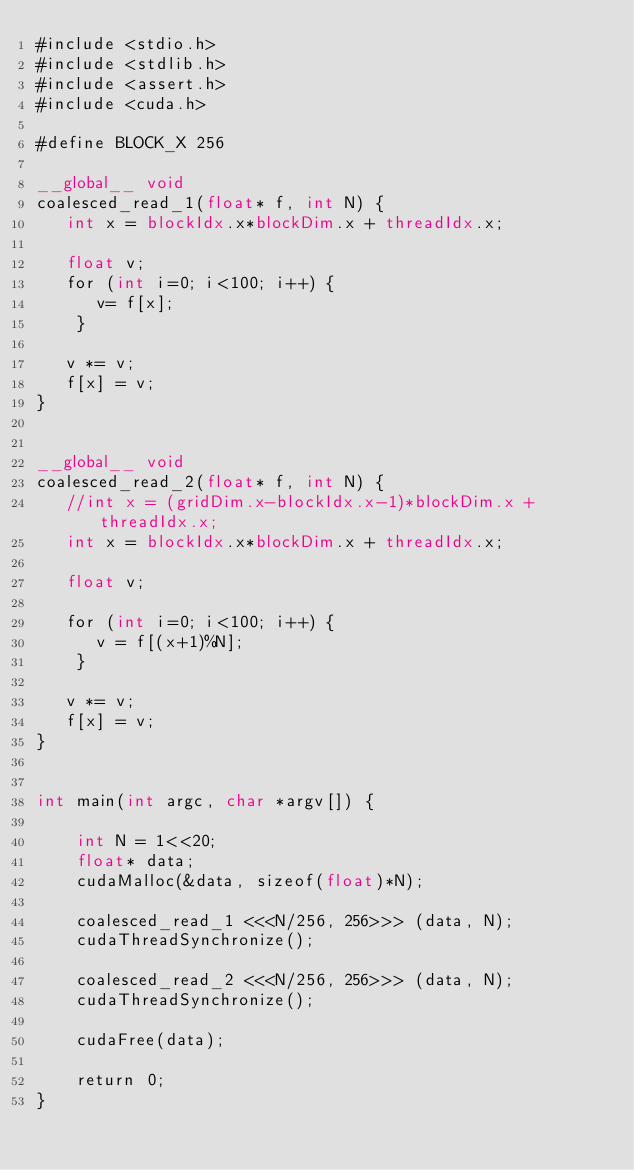Convert code to text. <code><loc_0><loc_0><loc_500><loc_500><_Cuda_>#include <stdio.h>  
#include <stdlib.h>
#include <assert.h>
#include <cuda.h>  

#define BLOCK_X 256

__global__ void
coalesced_read_1(float* f, int N) {
   int x = blockIdx.x*blockDim.x + threadIdx.x;
    
   float v;
   for (int i=0; i<100; i++) {
      v= f[x];
    }

   v *= v;
   f[x] = v;
}


__global__ void
coalesced_read_2(float* f, int N) {
   //int x = (gridDim.x-blockIdx.x-1)*blockDim.x + threadIdx.x;
   int x = blockIdx.x*blockDim.x + threadIdx.x;

   float v;

   for (int i=0; i<100; i++) {
      v = f[(x+1)%N];
    }

   v *= v;
   f[x] = v;
}


int main(int argc, char *argv[]) {

    int N = 1<<20;
    float* data;
    cudaMalloc(&data, sizeof(float)*N);

    coalesced_read_1 <<<N/256, 256>>> (data, N);
    cudaThreadSynchronize();

    coalesced_read_2 <<<N/256, 256>>> (data, N);
    cudaThreadSynchronize();

    cudaFree(data);

    return 0;
}
</code> 